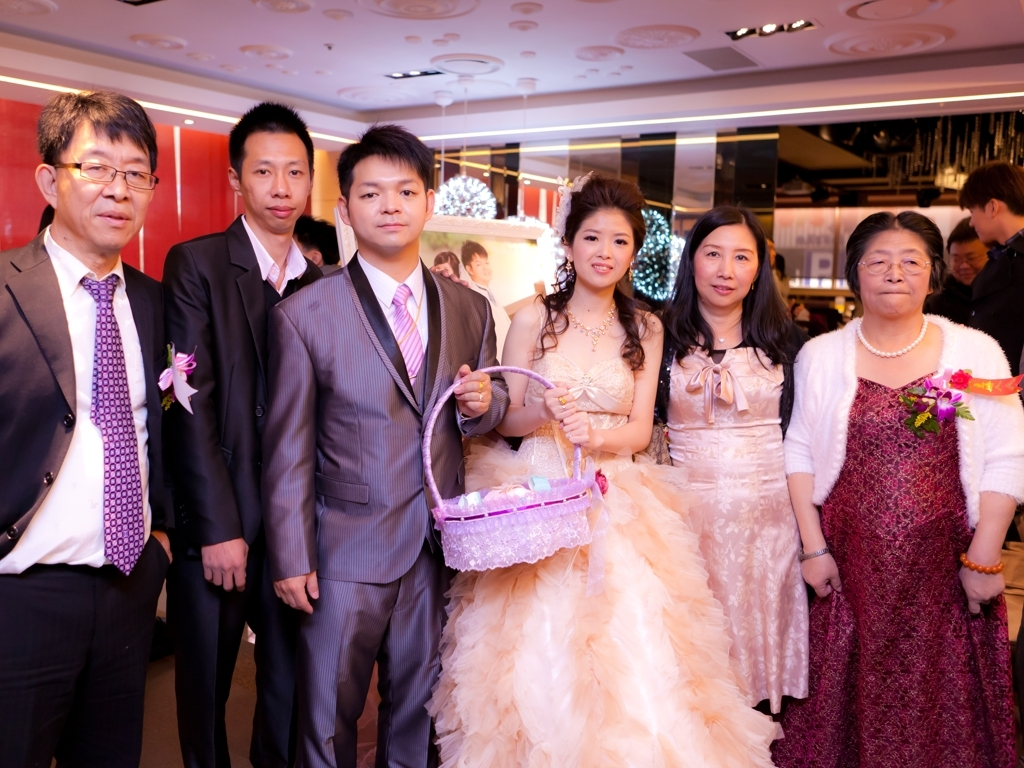Can you describe the event and the emotions conveyed by the people in the image? Based on the attire and the distinct flower arrangements, this image likely captures a moment from a formal event, possibly a wedding. The individuals appear dressed for a celebration, with the central pair, in particular, suggesting they could be the ones being celebrated – the bride and groom. The expressions on their faces display contentment and a sense of occasion. The other individuals may be family or close friends, their smiles and formal dress indicating a shared joy for the special day. The elderly person on the right shows a dignified happiness, commonly seen in older relatives proud to witness such milestones. 